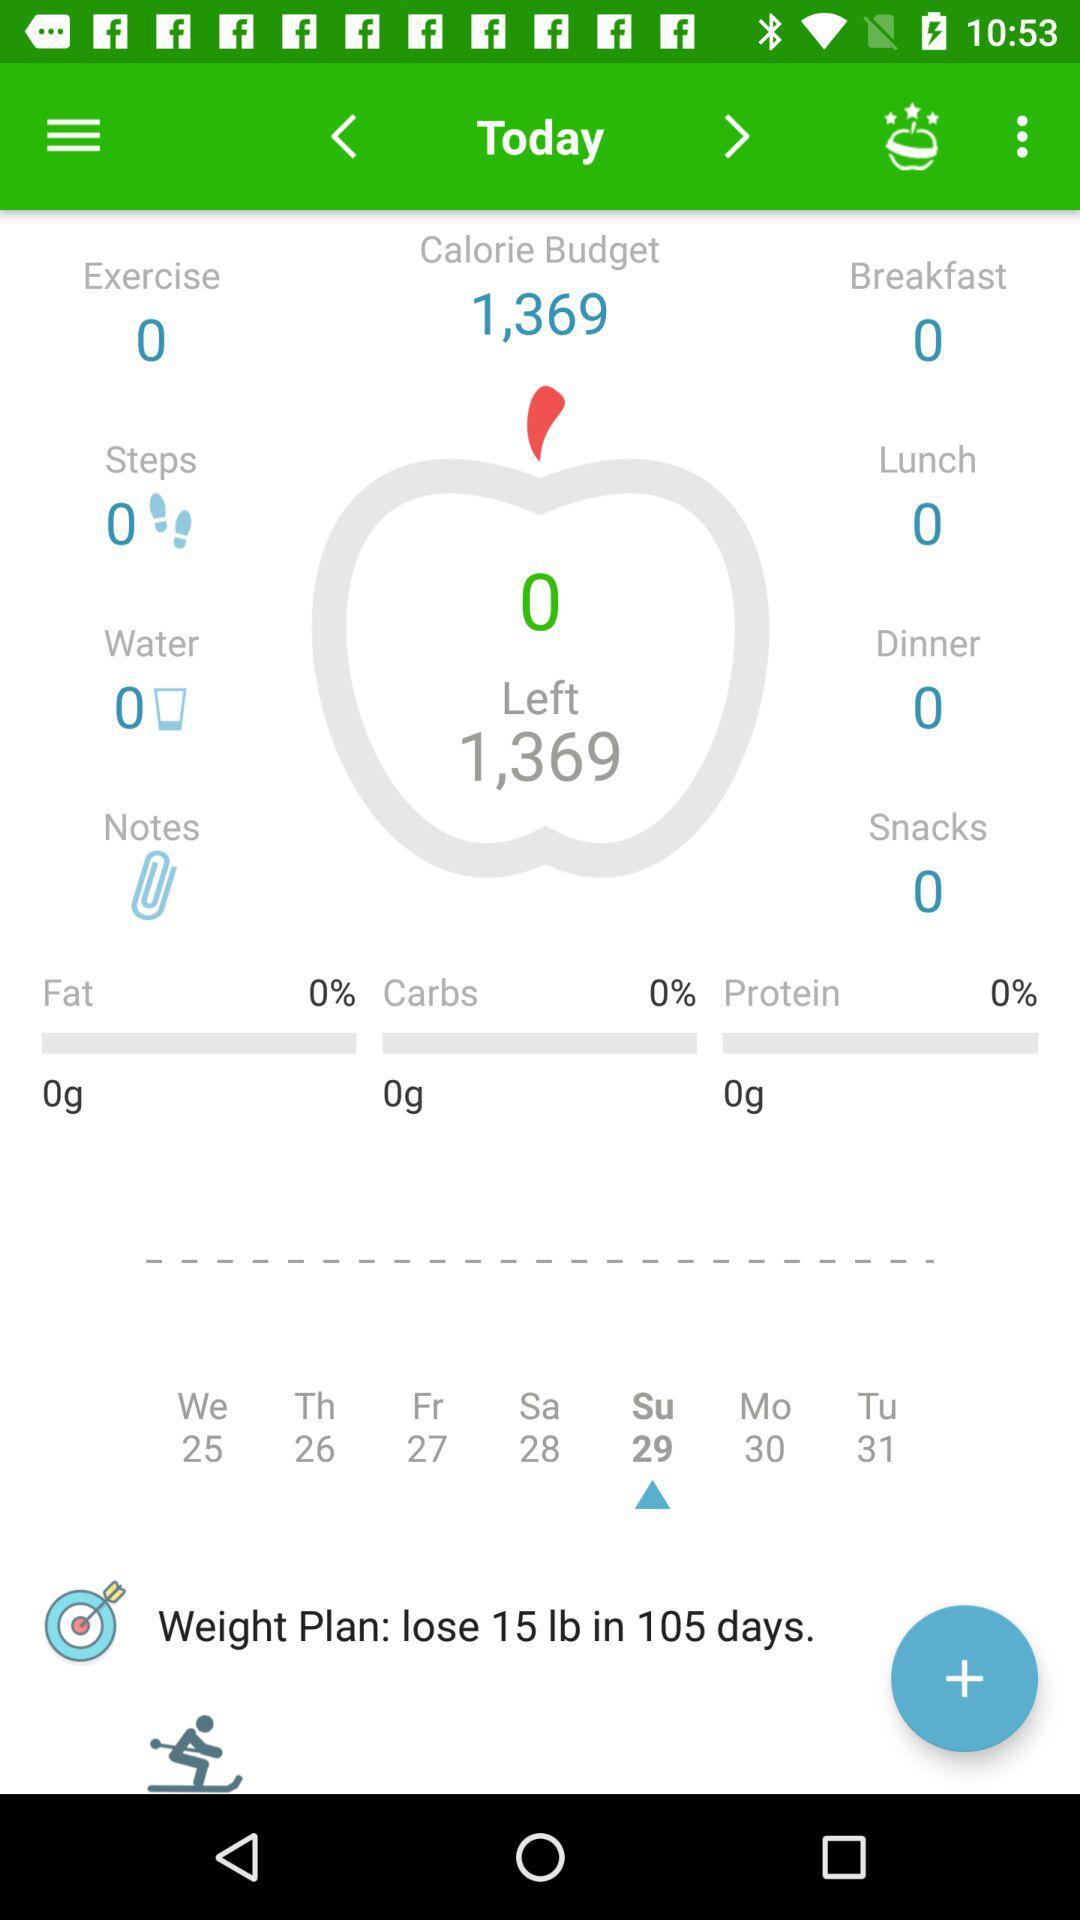What is the count of steps? The count of steps is 0. 